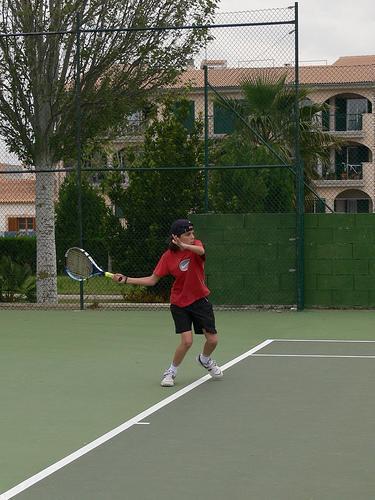How many people can you see?
Give a very brief answer. 1. How many birds are there?
Give a very brief answer. 0. 